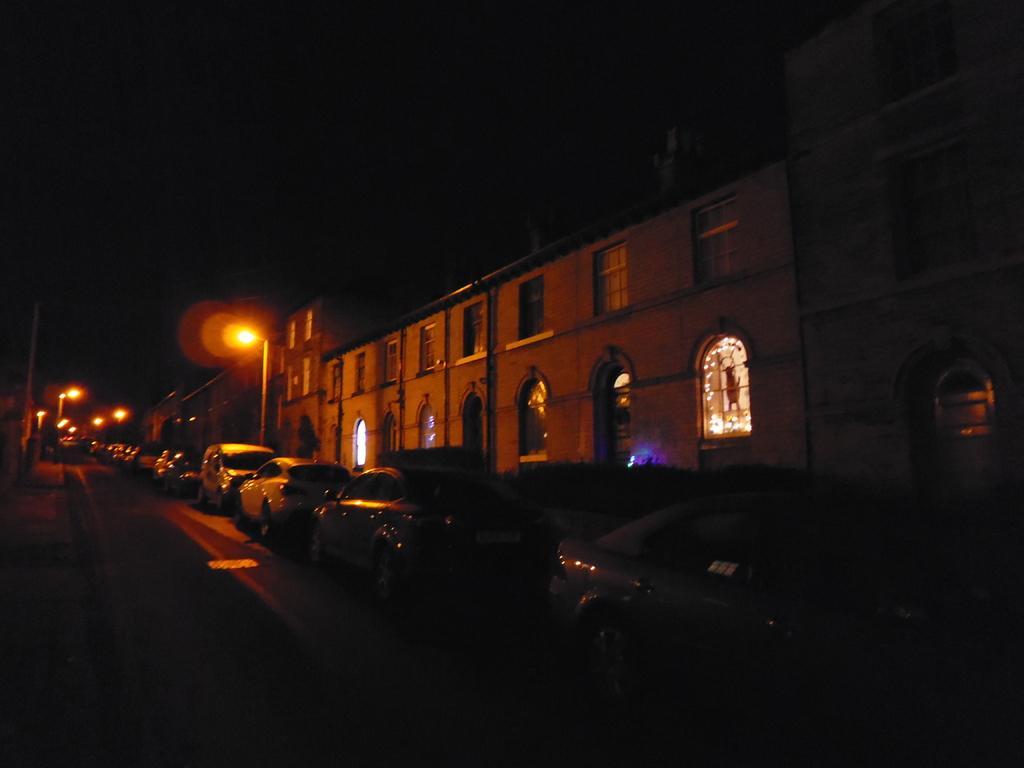Please provide a concise description of this image. In this image there are vehicles on the path , poles, lights, buildings, and in the background there is sky. 